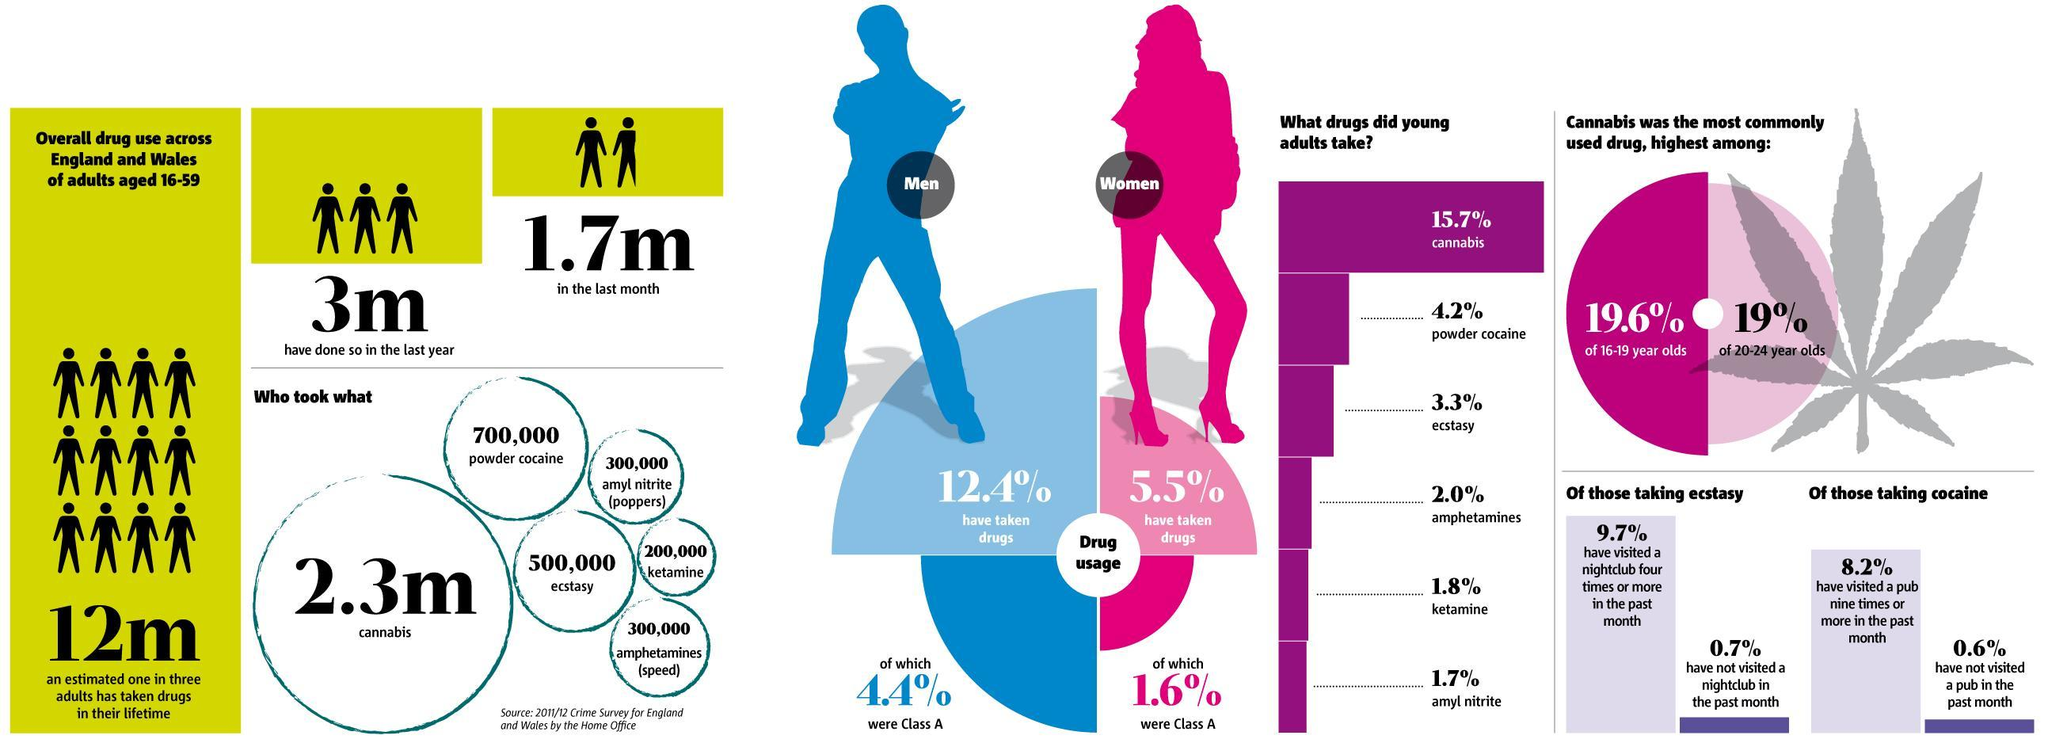What is the population of drug users in adults aged 16-59 across England & Wales in the last month according to 2011/2012 crime survey?
Answer the question with a short phrase. 1.7m What population of England & Wales used powder cocaine as per the 2011/2012 crime survey? 700,000 What percent of people in the age group of 16-19 year olds in England & Wales used Cannabis drug according to 2011/2012 crime survey? 19.6% What percentage of men aged 16-59 in England & Wales have taken drugs as per the 2011/2012 crime survey? 12.4% What percentage of powder cocaine was used by the young adults of England & Wales as per the 2011/2012 crime survey? 4.2% Which drug was used by majority of the young adults in England & Wales according to 2011/2012 crime survey? cannabis What percentage of drugs taken by men aged 16-59 in England & Wales were class A according to 2011/2012 survey? 4.4% What percentage of drugs taken by women aged 16-59 in England & Wales were class A according to 2011/2012 survey? 1.6% Which drug was least used by the young adults in England & Wales according to 2011/2012 crime survey? amyl nitrate What percent of people in the age group of 20-24 year olds in England & Wales used Cannabis drug according to 2011/2012 crime survey? 19% 